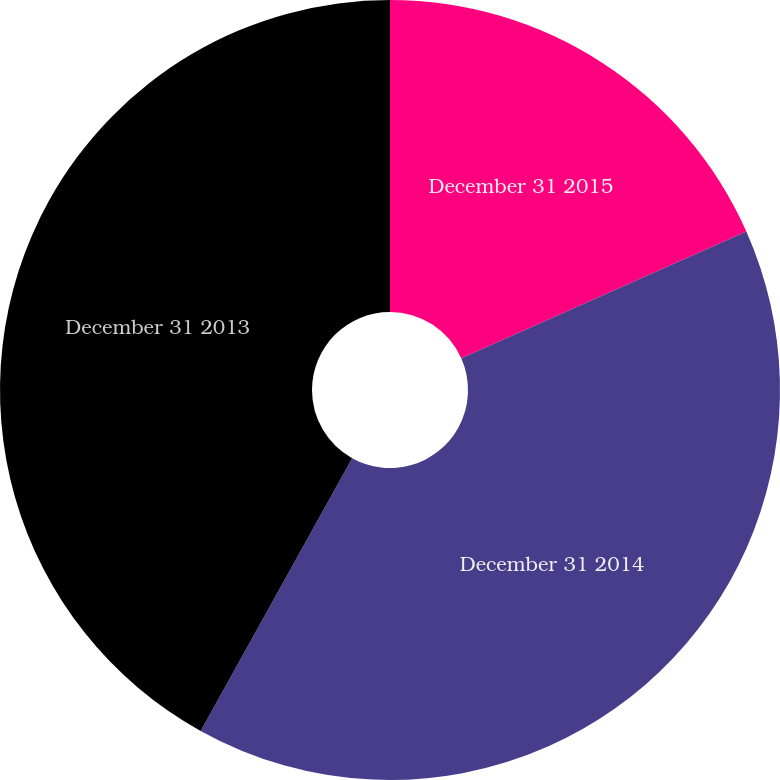Convert chart to OTSL. <chart><loc_0><loc_0><loc_500><loc_500><pie_chart><fcel>December 31 2015<fcel>December 31 2014<fcel>December 31 2013<nl><fcel>18.34%<fcel>39.73%<fcel>41.93%<nl></chart> 